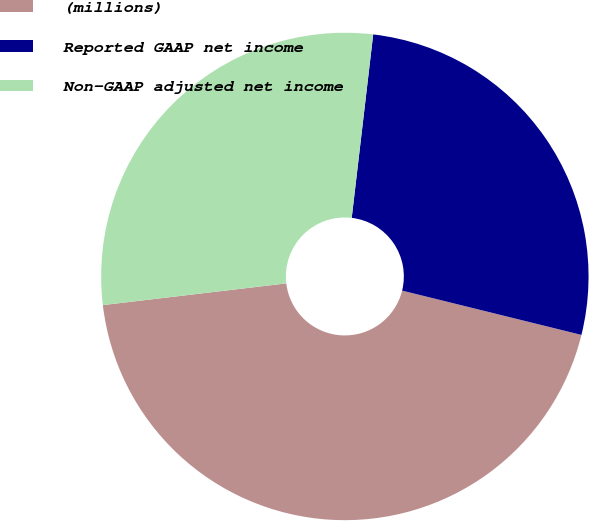Convert chart to OTSL. <chart><loc_0><loc_0><loc_500><loc_500><pie_chart><fcel>(millions)<fcel>Reported GAAP net income<fcel>Non-GAAP adjusted net income<nl><fcel>44.27%<fcel>27.0%<fcel>28.73%<nl></chart> 